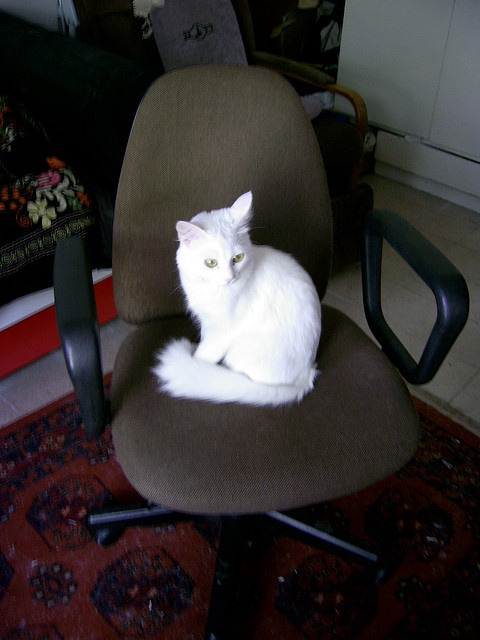Describe the objects in this image and their specific colors. I can see chair in blue, black, lavender, and gray tones, couch in blue, black, maroon, gray, and darkgreen tones, and cat in blue, lavender, darkgray, and gray tones in this image. 